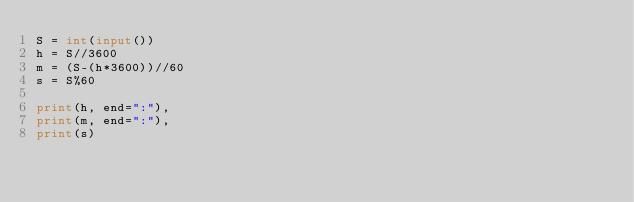<code> <loc_0><loc_0><loc_500><loc_500><_Python_>S = int(input())
h = S//3600
m = (S-(h*3600))//60
s = S%60

print(h, end=":"),
print(m, end=":"),
print(s)



</code> 